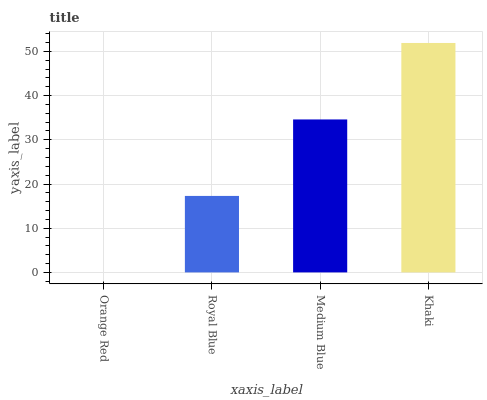Is Royal Blue the minimum?
Answer yes or no. No. Is Royal Blue the maximum?
Answer yes or no. No. Is Royal Blue greater than Orange Red?
Answer yes or no. Yes. Is Orange Red less than Royal Blue?
Answer yes or no. Yes. Is Orange Red greater than Royal Blue?
Answer yes or no. No. Is Royal Blue less than Orange Red?
Answer yes or no. No. Is Medium Blue the high median?
Answer yes or no. Yes. Is Royal Blue the low median?
Answer yes or no. Yes. Is Orange Red the high median?
Answer yes or no. No. Is Orange Red the low median?
Answer yes or no. No. 